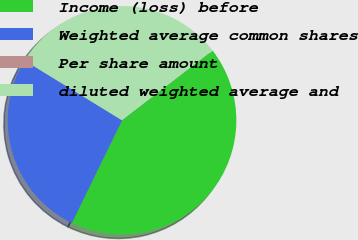<chart> <loc_0><loc_0><loc_500><loc_500><pie_chart><fcel>Income (loss) before<fcel>Weighted average common shares<fcel>Per share amount<fcel>diluted weighted average and<nl><fcel>42.67%<fcel>26.53%<fcel>0.0%<fcel>30.8%<nl></chart> 